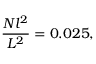Convert formula to latex. <formula><loc_0><loc_0><loc_500><loc_500>\frac { N l ^ { 2 } } { L ^ { 2 } } = 0 . 0 2 5 ,</formula> 